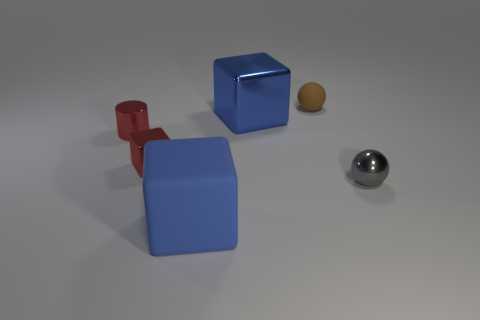What size is the cube that is the same color as the large metal object?
Provide a succinct answer. Large. What number of rubber objects are either tiny brown balls or large cyan blocks?
Your answer should be very brief. 1. There is a blue block on the left side of the large cube behind the blue matte thing; are there any large blue shiny things on the left side of it?
Your answer should be very brief. No. The gray thing that is the same material as the tiny cylinder is what size?
Ensure brevity in your answer.  Small. There is a big metallic thing; are there any tiny cylinders behind it?
Give a very brief answer. No. There is a block that is behind the metallic cylinder; is there a blue rubber object behind it?
Give a very brief answer. No. There is a blue thing that is behind the small metal sphere; is its size the same as the shiny block in front of the blue shiny cube?
Offer a very short reply. No. How many large objects are cubes or blue rubber blocks?
Your answer should be very brief. 2. There is a big thing to the right of the large blue object that is to the left of the large blue shiny block; what is it made of?
Offer a very short reply. Metal. The metallic thing that is the same color as the small cylinder is what shape?
Your answer should be very brief. Cube. 